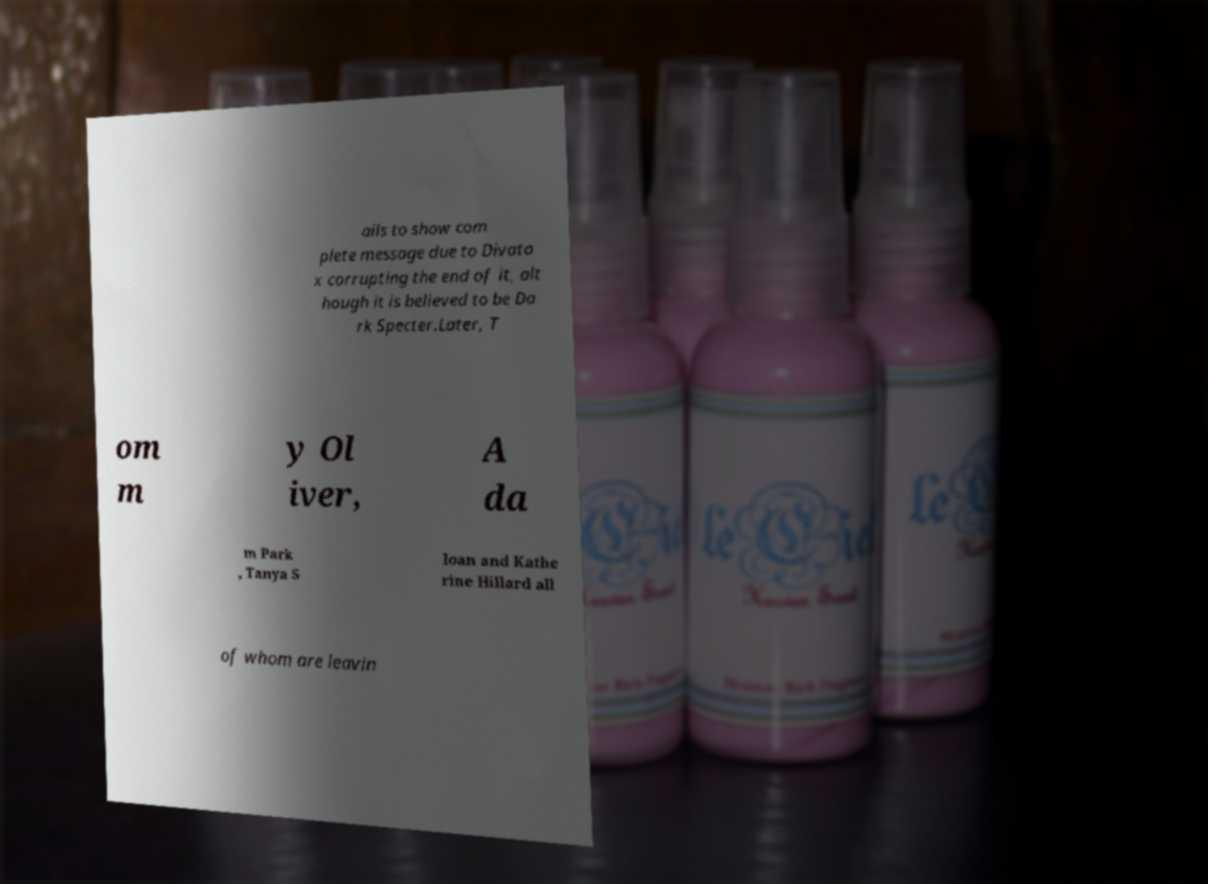I need the written content from this picture converted into text. Can you do that? ails to show com plete message due to Divato x corrupting the end of it, alt hough it is believed to be Da rk Specter.Later, T om m y Ol iver, A da m Park , Tanya S loan and Kathe rine Hillard all of whom are leavin 